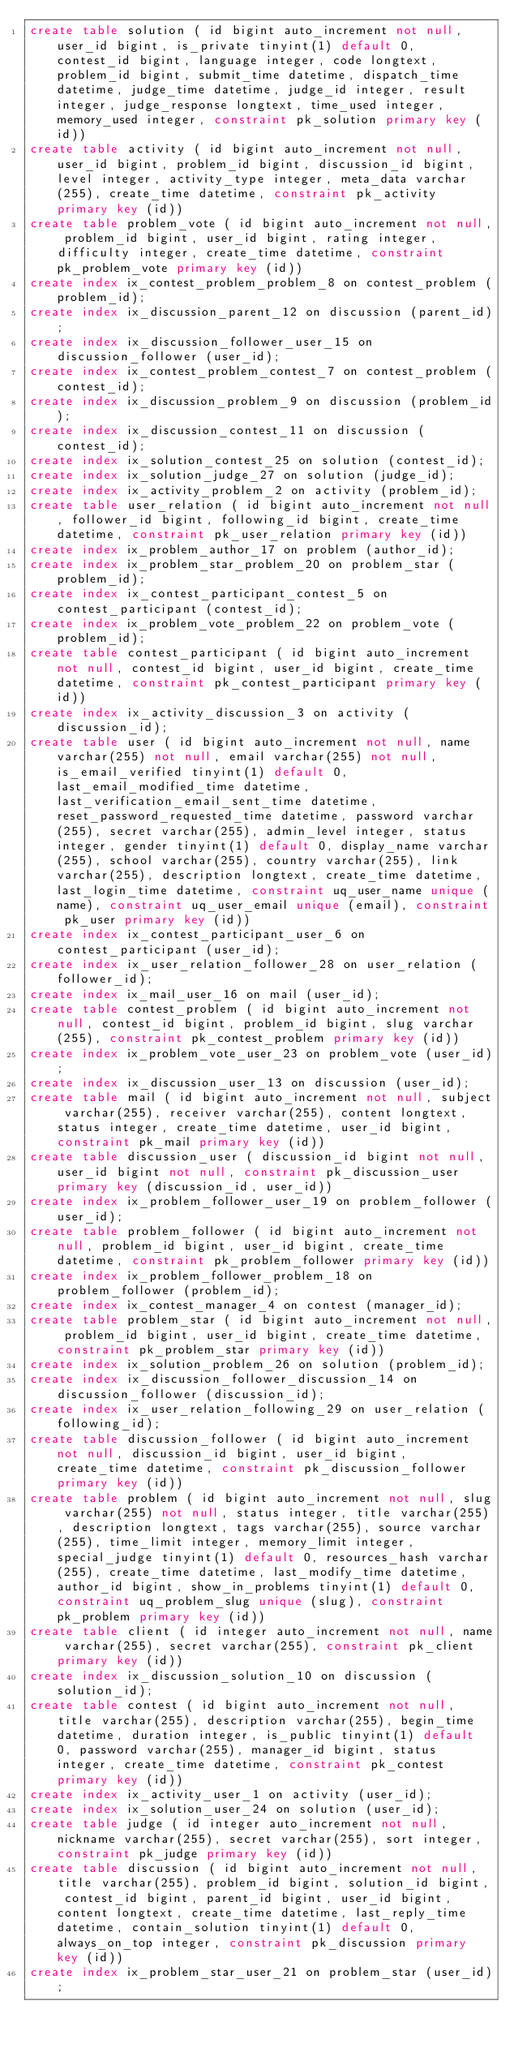<code> <loc_0><loc_0><loc_500><loc_500><_SQL_>create table solution ( id bigint auto_increment not null, user_id bigint, is_private tinyint(1) default 0, contest_id bigint, language integer, code longtext, problem_id bigint, submit_time datetime, dispatch_time datetime, judge_time datetime, judge_id integer, result integer, judge_response longtext, time_used integer, memory_used integer, constraint pk_solution primary key (id))
create table activity ( id bigint auto_increment not null, user_id bigint, problem_id bigint, discussion_id bigint, level integer, activity_type integer, meta_data varchar(255), create_time datetime, constraint pk_activity primary key (id))
create table problem_vote ( id bigint auto_increment not null, problem_id bigint, user_id bigint, rating integer, difficulty integer, create_time datetime, constraint pk_problem_vote primary key (id))
create index ix_contest_problem_problem_8 on contest_problem (problem_id);
create index ix_discussion_parent_12 on discussion (parent_id);
create index ix_discussion_follower_user_15 on discussion_follower (user_id);
create index ix_contest_problem_contest_7 on contest_problem (contest_id);
create index ix_discussion_problem_9 on discussion (problem_id);
create index ix_discussion_contest_11 on discussion (contest_id);
create index ix_solution_contest_25 on solution (contest_id);
create index ix_solution_judge_27 on solution (judge_id);
create index ix_activity_problem_2 on activity (problem_id);
create table user_relation ( id bigint auto_increment not null, follower_id bigint, following_id bigint, create_time datetime, constraint pk_user_relation primary key (id))
create index ix_problem_author_17 on problem (author_id);
create index ix_problem_star_problem_20 on problem_star (problem_id);
create index ix_contest_participant_contest_5 on contest_participant (contest_id);
create index ix_problem_vote_problem_22 on problem_vote (problem_id);
create table contest_participant ( id bigint auto_increment not null, contest_id bigint, user_id bigint, create_time datetime, constraint pk_contest_participant primary key (id))
create index ix_activity_discussion_3 on activity (discussion_id);
create table user ( id bigint auto_increment not null, name varchar(255) not null, email varchar(255) not null, is_email_verified tinyint(1) default 0, last_email_modified_time datetime, last_verification_email_sent_time datetime, reset_password_requested_time datetime, password varchar(255), secret varchar(255), admin_level integer, status integer, gender tinyint(1) default 0, display_name varchar(255), school varchar(255), country varchar(255), link varchar(255), description longtext, create_time datetime, last_login_time datetime, constraint uq_user_name unique (name), constraint uq_user_email unique (email), constraint pk_user primary key (id))
create index ix_contest_participant_user_6 on contest_participant (user_id);
create index ix_user_relation_follower_28 on user_relation (follower_id);
create index ix_mail_user_16 on mail (user_id);
create table contest_problem ( id bigint auto_increment not null, contest_id bigint, problem_id bigint, slug varchar(255), constraint pk_contest_problem primary key (id))
create index ix_problem_vote_user_23 on problem_vote (user_id);
create index ix_discussion_user_13 on discussion (user_id);
create table mail ( id bigint auto_increment not null, subject varchar(255), receiver varchar(255), content longtext, status integer, create_time datetime, user_id bigint, constraint pk_mail primary key (id))
create table discussion_user ( discussion_id bigint not null, user_id bigint not null, constraint pk_discussion_user primary key (discussion_id, user_id))
create index ix_problem_follower_user_19 on problem_follower (user_id);
create table problem_follower ( id bigint auto_increment not null, problem_id bigint, user_id bigint, create_time datetime, constraint pk_problem_follower primary key (id))
create index ix_problem_follower_problem_18 on problem_follower (problem_id);
create index ix_contest_manager_4 on contest (manager_id);
create table problem_star ( id bigint auto_increment not null, problem_id bigint, user_id bigint, create_time datetime, constraint pk_problem_star primary key (id))
create index ix_solution_problem_26 on solution (problem_id);
create index ix_discussion_follower_discussion_14 on discussion_follower (discussion_id);
create index ix_user_relation_following_29 on user_relation (following_id);
create table discussion_follower ( id bigint auto_increment not null, discussion_id bigint, user_id bigint, create_time datetime, constraint pk_discussion_follower primary key (id))
create table problem ( id bigint auto_increment not null, slug varchar(255) not null, status integer, title varchar(255), description longtext, tags varchar(255), source varchar(255), time_limit integer, memory_limit integer, special_judge tinyint(1) default 0, resources_hash varchar(255), create_time datetime, last_modify_time datetime, author_id bigint, show_in_problems tinyint(1) default 0, constraint uq_problem_slug unique (slug), constraint pk_problem primary key (id))
create table client ( id integer auto_increment not null, name varchar(255), secret varchar(255), constraint pk_client primary key (id))
create index ix_discussion_solution_10 on discussion (solution_id);
create table contest ( id bigint auto_increment not null, title varchar(255), description varchar(255), begin_time datetime, duration integer, is_public tinyint(1) default 0, password varchar(255), manager_id bigint, status integer, create_time datetime, constraint pk_contest primary key (id))
create index ix_activity_user_1 on activity (user_id);
create index ix_solution_user_24 on solution (user_id);
create table judge ( id integer auto_increment not null, nickname varchar(255), secret varchar(255), sort integer, constraint pk_judge primary key (id))
create table discussion ( id bigint auto_increment not null, title varchar(255), problem_id bigint, solution_id bigint, contest_id bigint, parent_id bigint, user_id bigint, content longtext, create_time datetime, last_reply_time datetime, contain_solution tinyint(1) default 0, always_on_top integer, constraint pk_discussion primary key (id))
create index ix_problem_star_user_21 on problem_star (user_id);
</code> 